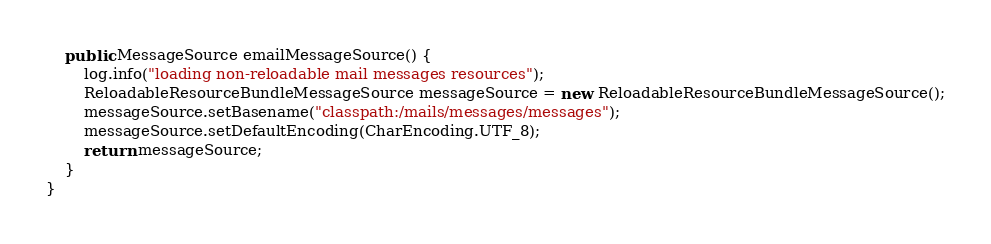<code> <loc_0><loc_0><loc_500><loc_500><_Java_>    public MessageSource emailMessageSource() {
        log.info("loading non-reloadable mail messages resources");
        ReloadableResourceBundleMessageSource messageSource = new ReloadableResourceBundleMessageSource();
        messageSource.setBasename("classpath:/mails/messages/messages");
        messageSource.setDefaultEncoding(CharEncoding.UTF_8);
        return messageSource;
    }
}
</code> 